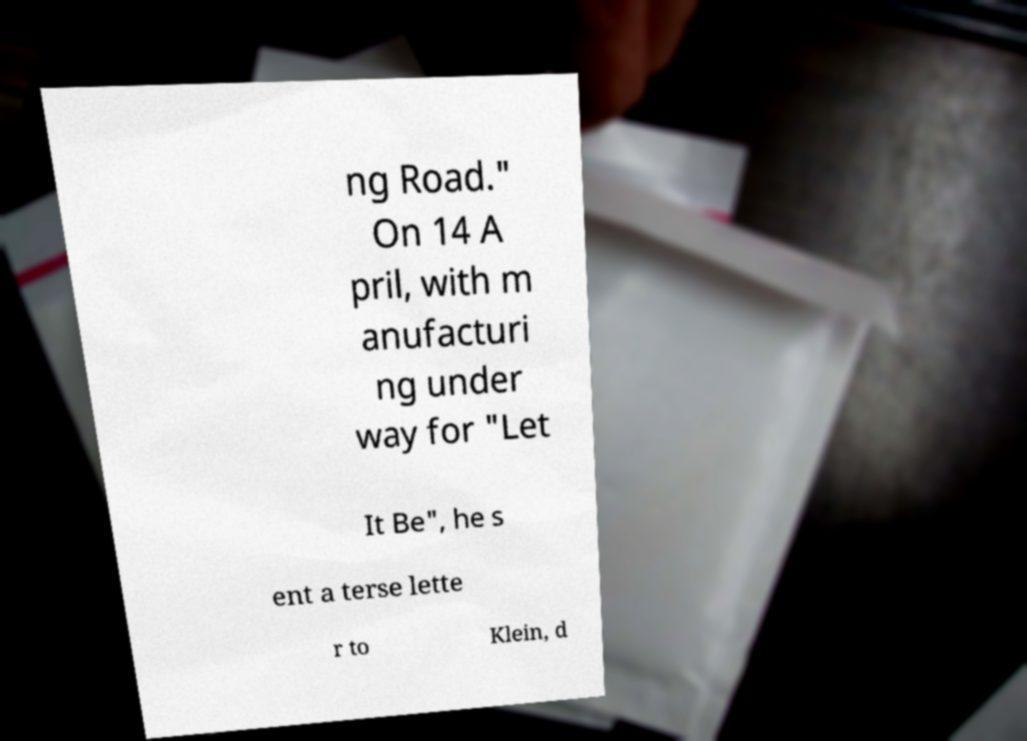Please read and relay the text visible in this image. What does it say? ng Road." On 14 A pril, with m anufacturi ng under way for "Let It Be", he s ent a terse lette r to Klein, d 